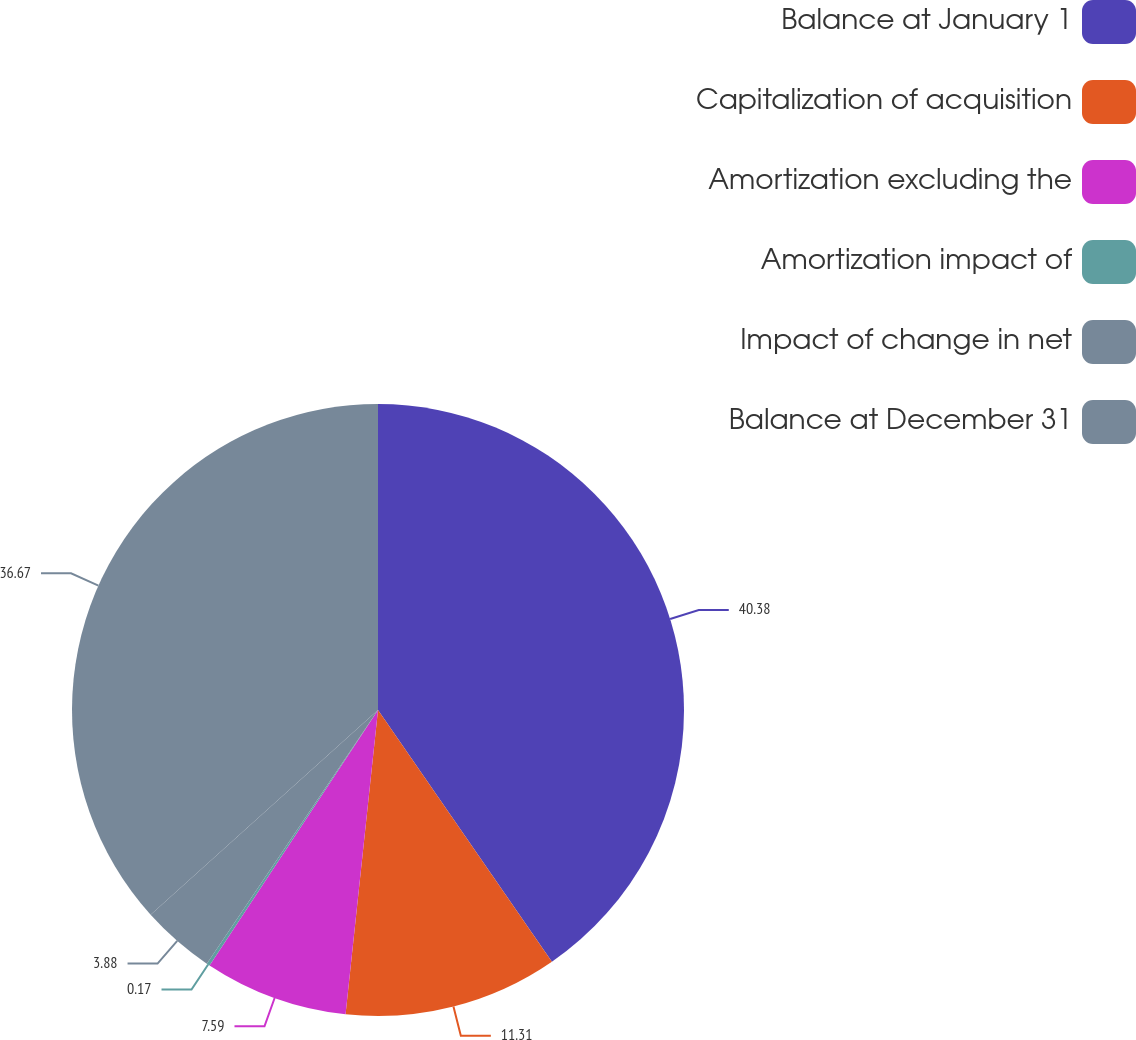Convert chart. <chart><loc_0><loc_0><loc_500><loc_500><pie_chart><fcel>Balance at January 1<fcel>Capitalization of acquisition<fcel>Amortization excluding the<fcel>Amortization impact of<fcel>Impact of change in net<fcel>Balance at December 31<nl><fcel>40.38%<fcel>11.31%<fcel>7.59%<fcel>0.17%<fcel>3.88%<fcel>36.67%<nl></chart> 